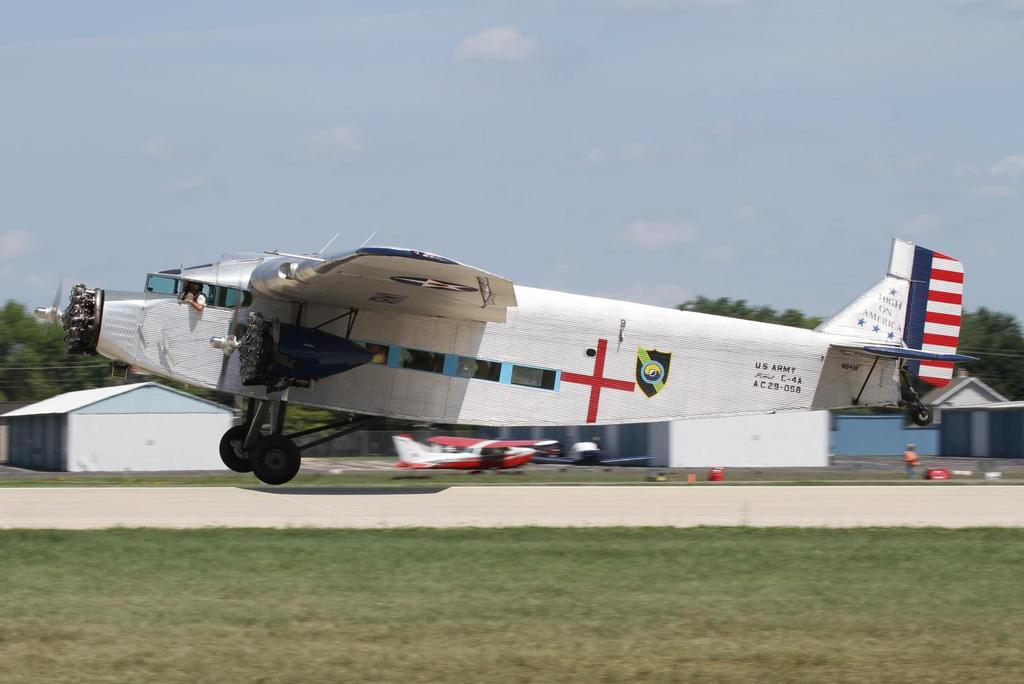<image>
Create a compact narrative representing the image presented. A white older style airplane is taking off into the air and it says army on the side. 